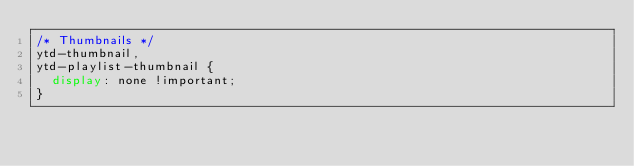Convert code to text. <code><loc_0><loc_0><loc_500><loc_500><_CSS_>/* Thumbnails */
ytd-thumbnail,
ytd-playlist-thumbnail {
	display: none !important;
}</code> 